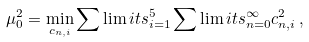<formula> <loc_0><loc_0><loc_500><loc_500>\mu _ { 0 } ^ { 2 } = \min _ { c _ { n , i } } \sum \lim i t s _ { i = 1 } ^ { 5 } \sum \lim i t s _ { n = 0 } ^ { \infty } c _ { n , i } ^ { 2 } \, ,</formula> 